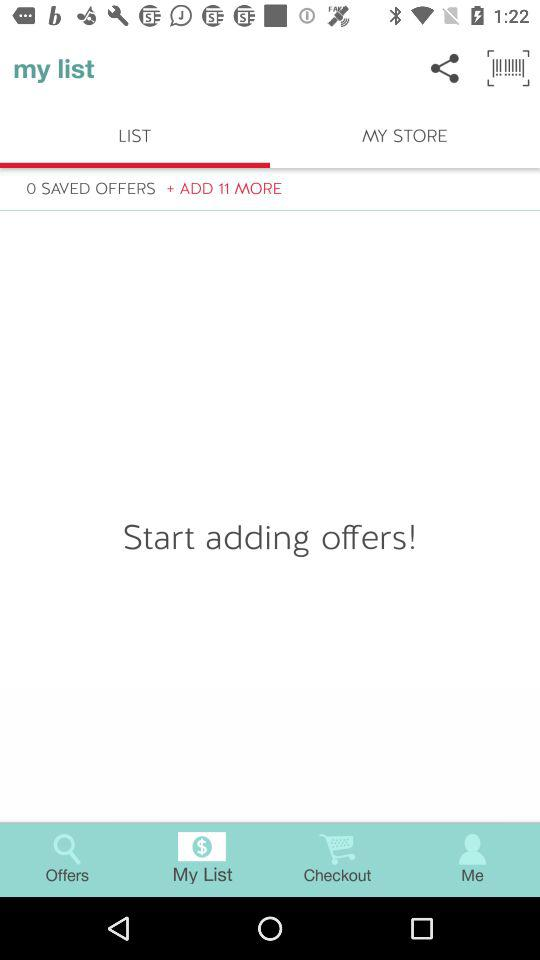How many more offers can be added?
Answer the question using a single word or phrase. 11 